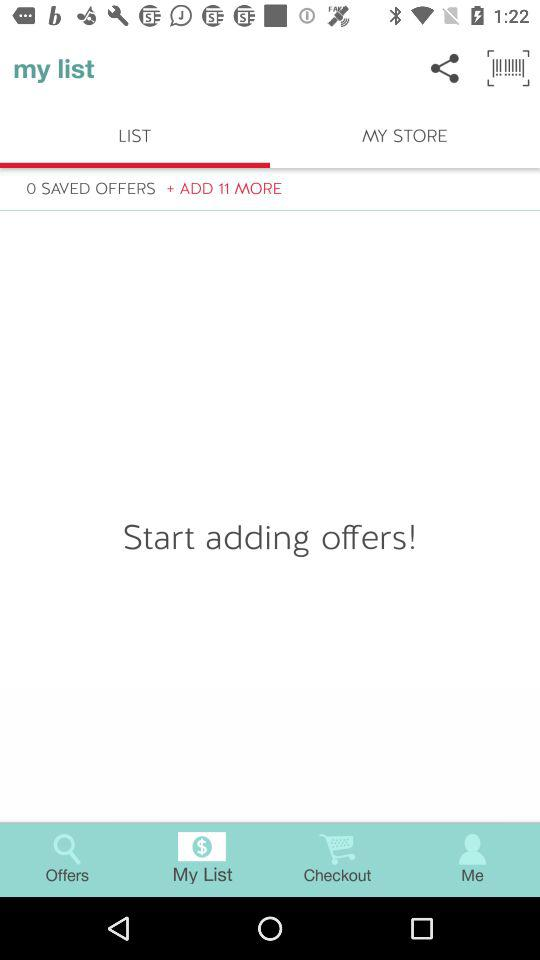How many more offers can be added?
Answer the question using a single word or phrase. 11 